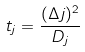<formula> <loc_0><loc_0><loc_500><loc_500>t _ { j } = \frac { ( \Delta j ) ^ { 2 } } { D _ { j } }</formula> 